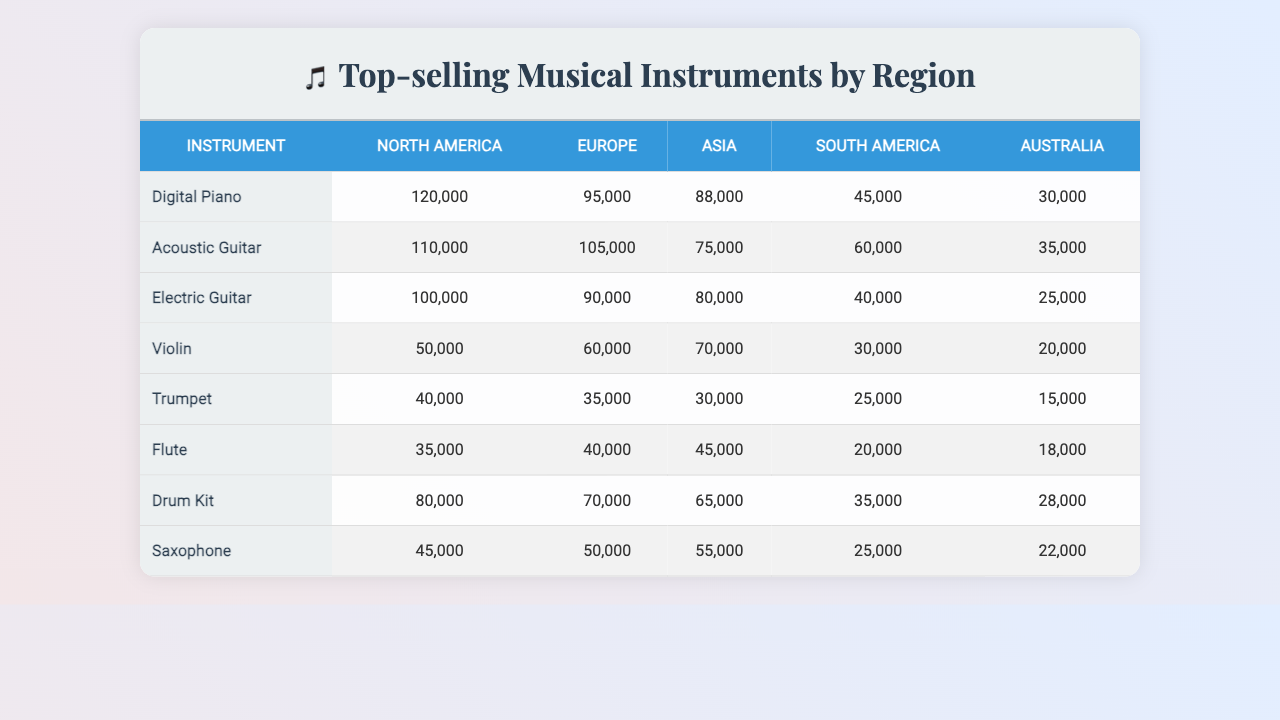What is the top-selling instrument in North America? From the table, we can look at the sales numbers for each instrument in North America. The Digital Piano has the highest sales figure of 120,000.
Answer: Digital Piano Which instrument sold the least in Australia? In the Australia column, the sales figures are 40,000 (Digital Piano), 35,000 (Acoustic Guitar), 30,000 (Electric Guitar), 25,000 (Violin), and 15,000 (Trumpet). The lowest value is 15,000 for the Trumpet.
Answer: Trumpet How many more Acoustic Guitars were sold in Europe than in South America? The sales figures for Acoustic Guitars are 105,000 in Europe and 60,000 in South America. The difference is 105,000 - 60,000 = 45,000.
Answer: 45,000 What is the average sales for Electric Guitars across all regions? The sales figures are 88,000 (North America), 75,000 (Europe), 80,000 (Asia), 70,000 (South America), and 30,000 (Australia). Adding them gives 88,000 + 75,000 + 80,000 + 70,000 + 30,000 = 343,000. Dividing by 5 gives an average of 343,000 / 5 = 68,600.
Answer: 68,600 Did more Drum Kits sell in Asia compared to North America? In Asia, Drum Kits sold 40,000, while in North America, they sold 80,000. Since 80,000 is greater than 40,000, the answer is yes.
Answer: Yes What is the total number of Violins sold across all regions? The sales figures for Violins across regions are 45,000 (North America), 60,000 (Europe), 40,000 (Asia), 30,000 (South America), and 25,000 (Australia). Adding them gives 45,000 + 60,000 + 40,000 + 30,000 + 25,000 = 200,000.
Answer: 200,000 Which region sold the most Flutes in the past year? The sales figures for Flutes are North America: 30,000, Europe: 35,000, Asia: 25,000, South America: 20,000, Australia: 18,000. The highest sales are in Europe with 35,000.
Answer: Europe What is the combined sales of Digital Pianos and Acoustic Guitars in South America? In South America, Digital Pianos sold 50,000 and Acoustic Guitars sold 60,000. The combined total is 50,000 + 60,000 = 110,000.
Answer: 110,000 Is it true that the sales of the Electric Guitar in North America is greater than the total sales of the Flute in all regions? The Electric Guitar in North America sold 88,000, while the Flute sales across regions are 30,000 (North America), 35,000 (Europe), 25,000 (Asia), 20,000 (South America), and 18,000 (Australia), totaling 128,000. Since 88,000 is not greater, the answer is false.
Answer: False Which instrument had the widest sales disparity between its best and worst regions? Looking at all instruments, the biggest disparity is for the Violin: 45,000 in North America and 25,000 in Australia, giving a difference of 20,000. No other instrument exceeds this difference.
Answer: Violin 